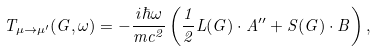<formula> <loc_0><loc_0><loc_500><loc_500>T _ { \mu \to \mu ^ { \prime } } ( { G } , \omega ) = - \frac { i \hbar { \omega } } { m c ^ { 2 } } \left ( \frac { 1 } { 2 } { L } ( { G } ) \cdot { A } ^ { \prime \prime } + { S } ( { G } ) \cdot { B } \right ) ,</formula> 